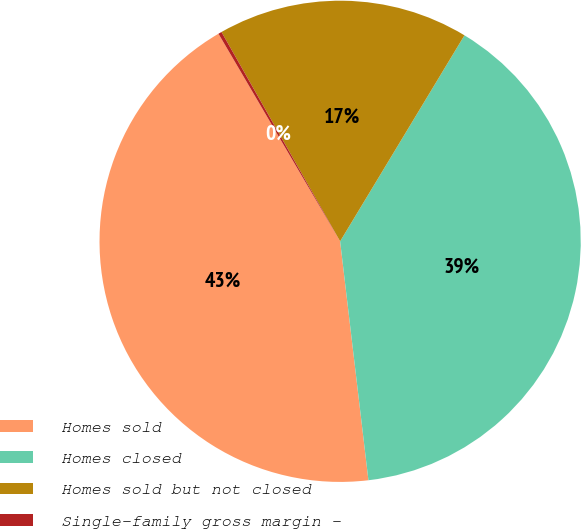<chart> <loc_0><loc_0><loc_500><loc_500><pie_chart><fcel>Homes sold<fcel>Homes closed<fcel>Homes sold but not closed<fcel>Single-family gross margin -<nl><fcel>43.44%<fcel>39.48%<fcel>16.85%<fcel>0.23%<nl></chart> 